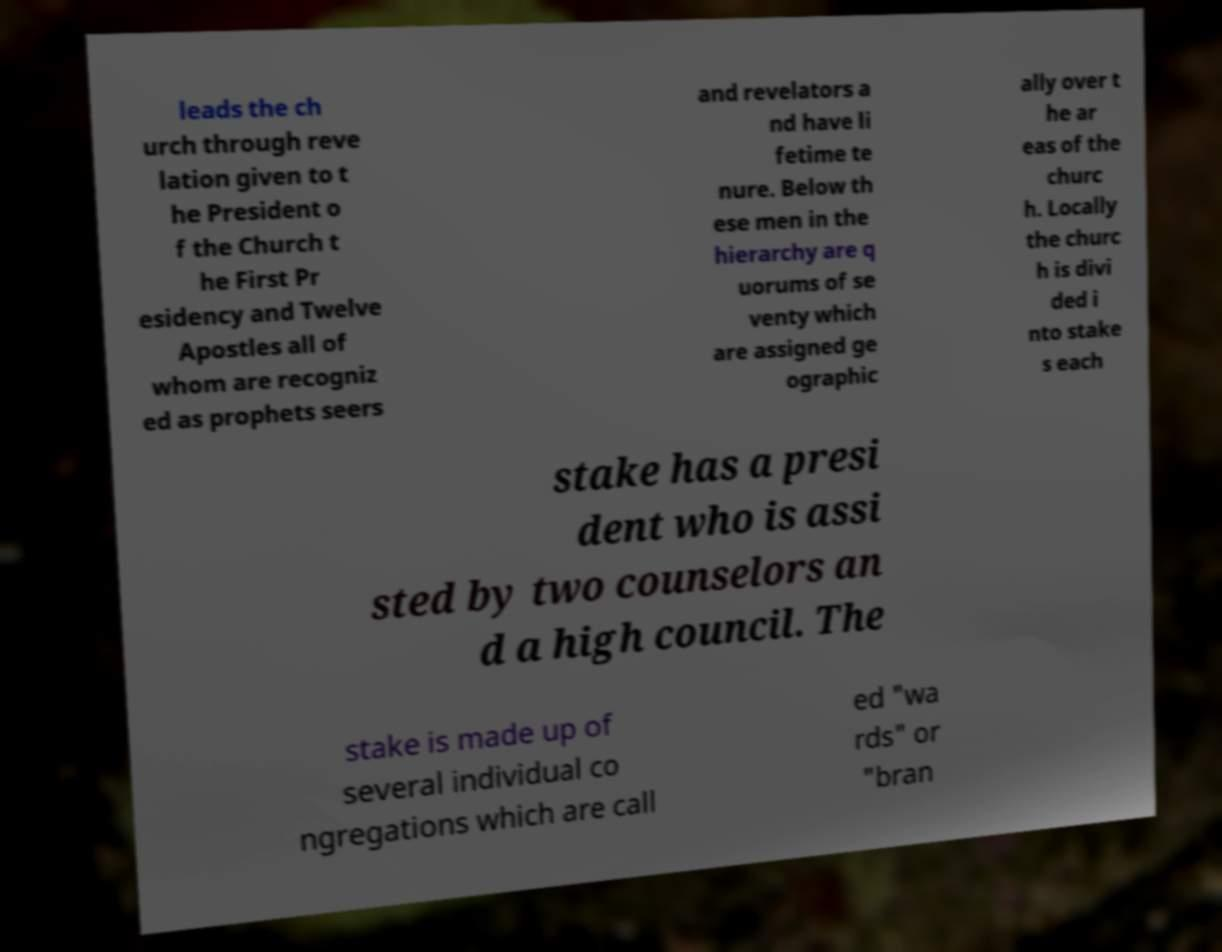Can you accurately transcribe the text from the provided image for me? leads the ch urch through reve lation given to t he President o f the Church t he First Pr esidency and Twelve Apostles all of whom are recogniz ed as prophets seers and revelators a nd have li fetime te nure. Below th ese men in the hierarchy are q uorums of se venty which are assigned ge ographic ally over t he ar eas of the churc h. Locally the churc h is divi ded i nto stake s each stake has a presi dent who is assi sted by two counselors an d a high council. The stake is made up of several individual co ngregations which are call ed "wa rds" or "bran 